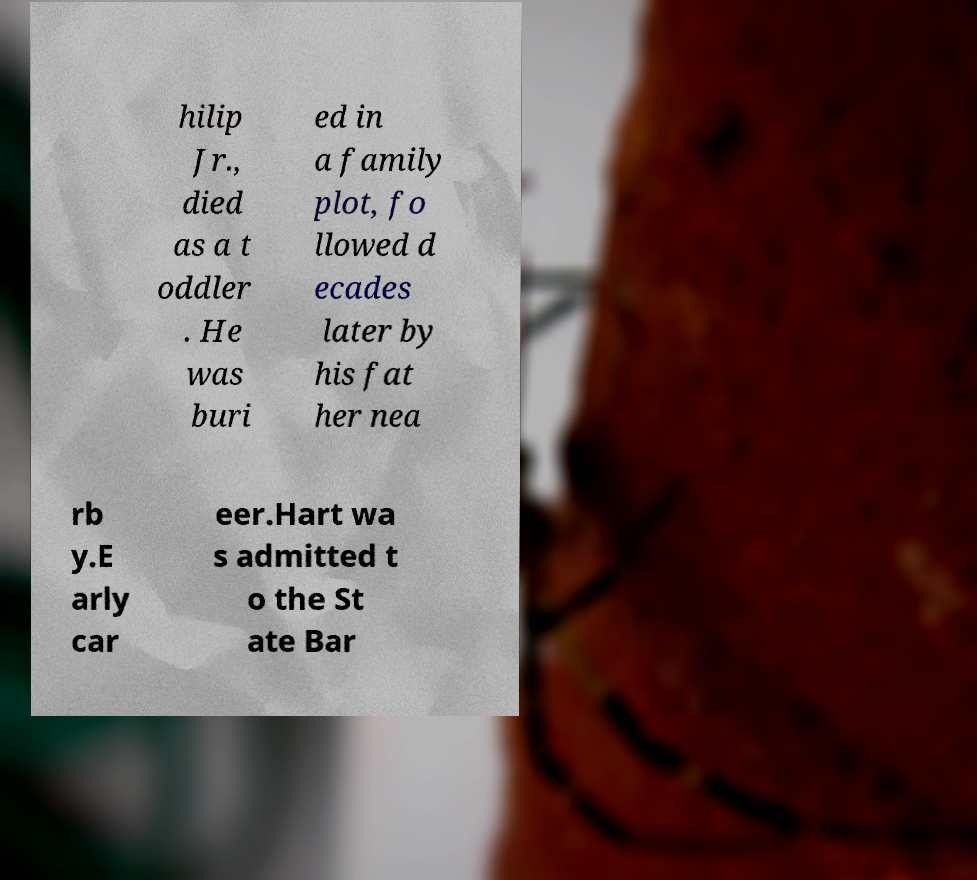Please identify and transcribe the text found in this image. hilip Jr., died as a t oddler . He was buri ed in a family plot, fo llowed d ecades later by his fat her nea rb y.E arly car eer.Hart wa s admitted t o the St ate Bar 